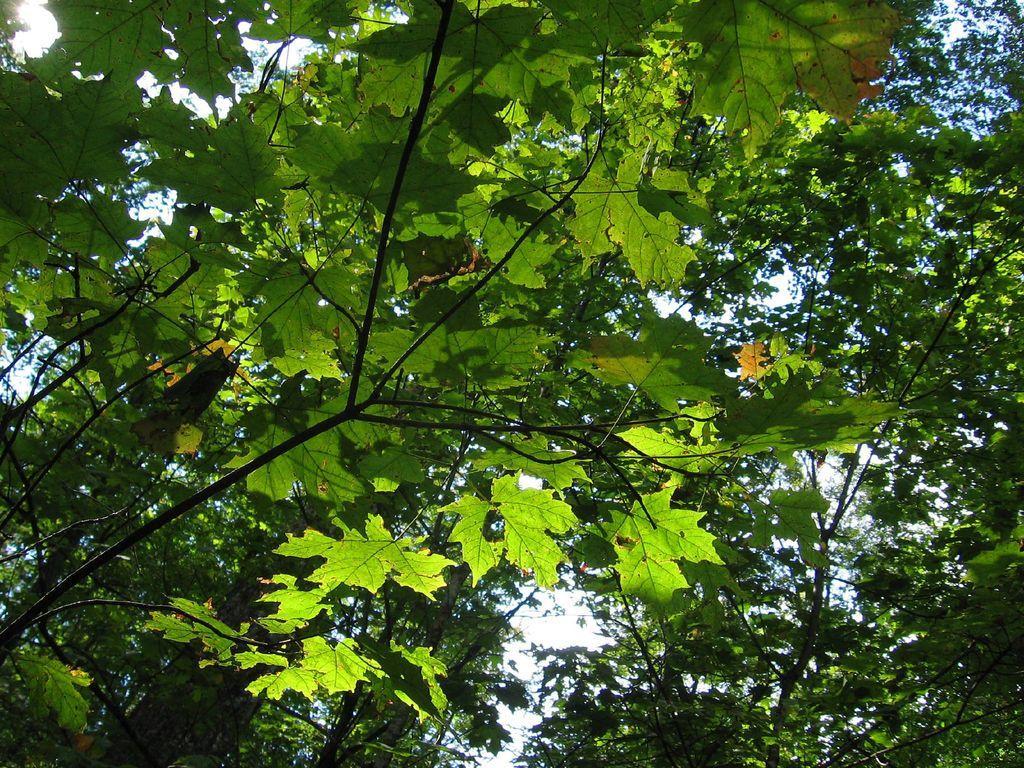Can you describe this image briefly? The picture consists of trees, where we can see the leaves, stems and branches. At the top it is sky. 